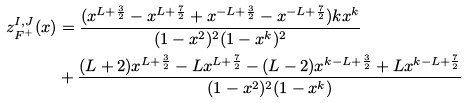<formula> <loc_0><loc_0><loc_500><loc_500>z ^ { I , J } _ { F ^ { + } } ( x ) & = \frac { ( x ^ { L + \frac { 3 } { 2 } } - x ^ { L + \frac { 7 } { 2 } } + x ^ { - L + \frac { 3 } { 2 } } - x ^ { - L + \frac { 7 } { 2 } } ) k x ^ { k } } { ( 1 - x ^ { 2 } ) ^ { 2 } ( 1 - x ^ { k } ) ^ { 2 } } \\ & + \frac { ( L + 2 ) x ^ { L + \frac { 3 } { 2 } } - L x ^ { L + \frac { 7 } { 2 } } - ( L - 2 ) x ^ { k - L + \frac { 3 } { 2 } } + L x ^ { k - L + \frac { 7 } { 2 } } } { ( 1 - x ^ { 2 } ) ^ { 2 } ( 1 - x ^ { k } ) }</formula> 